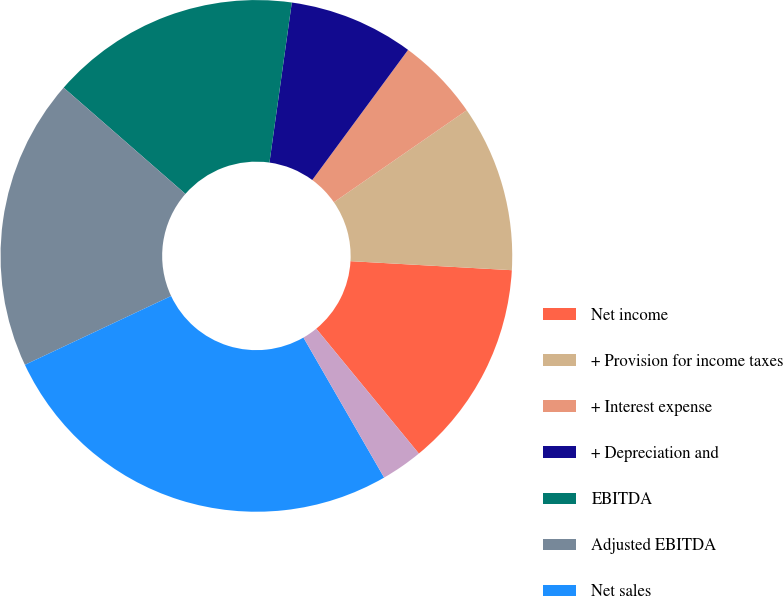<chart> <loc_0><loc_0><loc_500><loc_500><pie_chart><fcel>Net income<fcel>+ Provision for income taxes<fcel>+ Interest expense<fcel>+ Depreciation and<fcel>EBITDA<fcel>Adjusted EBITDA<fcel>Net sales<fcel>EBITDA margin<fcel>Adjusted EBITDA margin<nl><fcel>13.16%<fcel>10.53%<fcel>5.26%<fcel>7.89%<fcel>15.79%<fcel>18.42%<fcel>26.32%<fcel>0.0%<fcel>2.63%<nl></chart> 